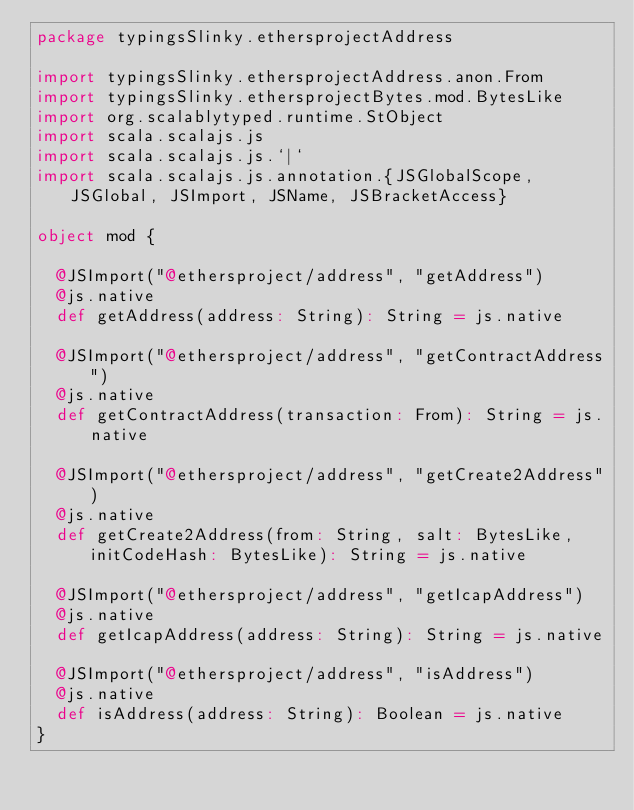Convert code to text. <code><loc_0><loc_0><loc_500><loc_500><_Scala_>package typingsSlinky.ethersprojectAddress

import typingsSlinky.ethersprojectAddress.anon.From
import typingsSlinky.ethersprojectBytes.mod.BytesLike
import org.scalablytyped.runtime.StObject
import scala.scalajs.js
import scala.scalajs.js.`|`
import scala.scalajs.js.annotation.{JSGlobalScope, JSGlobal, JSImport, JSName, JSBracketAccess}

object mod {
  
  @JSImport("@ethersproject/address", "getAddress")
  @js.native
  def getAddress(address: String): String = js.native
  
  @JSImport("@ethersproject/address", "getContractAddress")
  @js.native
  def getContractAddress(transaction: From): String = js.native
  
  @JSImport("@ethersproject/address", "getCreate2Address")
  @js.native
  def getCreate2Address(from: String, salt: BytesLike, initCodeHash: BytesLike): String = js.native
  
  @JSImport("@ethersproject/address", "getIcapAddress")
  @js.native
  def getIcapAddress(address: String): String = js.native
  
  @JSImport("@ethersproject/address", "isAddress")
  @js.native
  def isAddress(address: String): Boolean = js.native
}
</code> 